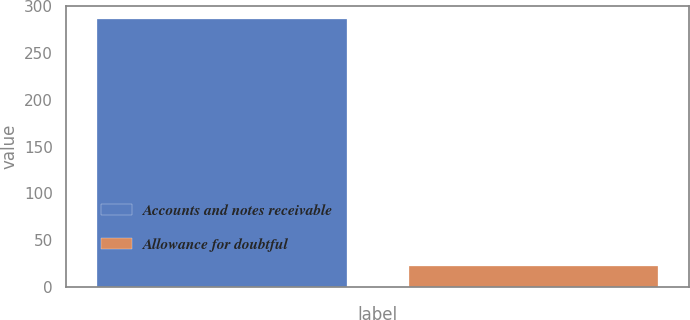Convert chart. <chart><loc_0><loc_0><loc_500><loc_500><bar_chart><fcel>Accounts and notes receivable<fcel>Allowance for doubtful<nl><fcel>286<fcel>22<nl></chart> 